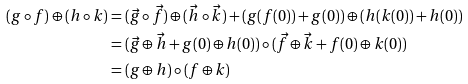Convert formula to latex. <formula><loc_0><loc_0><loc_500><loc_500>( g \circ f ) \oplus ( h \circ k ) & = ( \vec { g } \circ \vec { f } ) \oplus ( \vec { h } \circ \vec { k } ) + ( g ( f ( 0 ) ) + g ( 0 ) ) \oplus ( h ( k ( 0 ) ) + h ( 0 ) ) \\ & = ( \vec { g } \oplus \vec { h } + g ( 0 ) \oplus h ( 0 ) ) \circ ( \vec { f } \oplus \vec { k } + f ( 0 ) \oplus k ( 0 ) ) \\ & = ( g \oplus h ) \circ ( f \oplus k )</formula> 